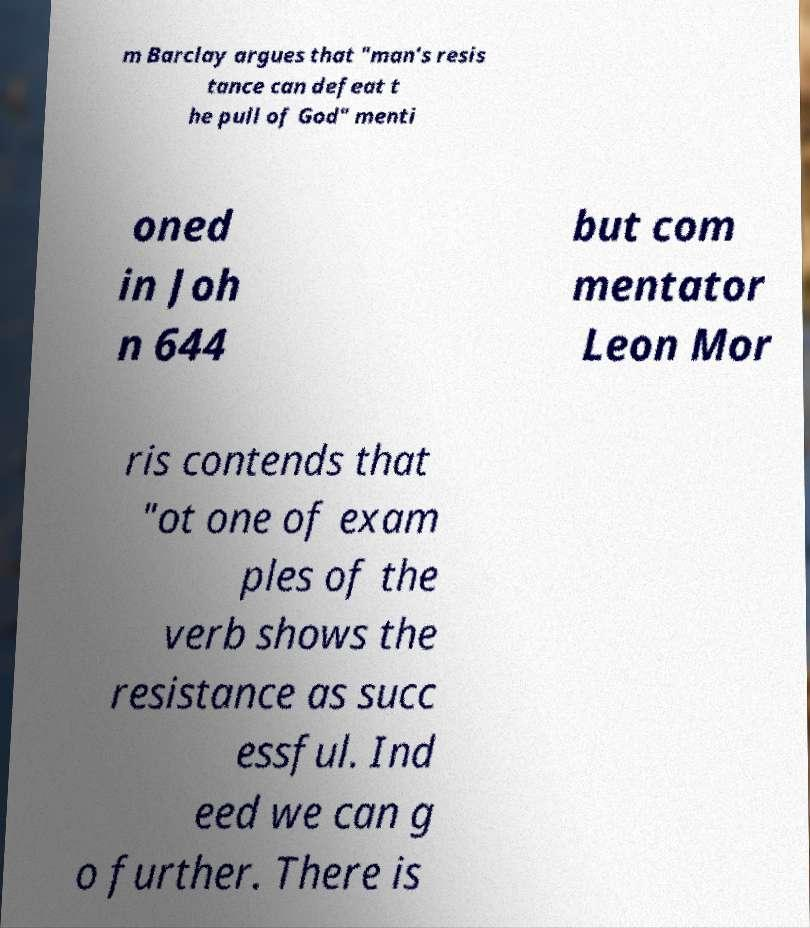Please read and relay the text visible in this image. What does it say? m Barclay argues that "man's resis tance can defeat t he pull of God" menti oned in Joh n 644 but com mentator Leon Mor ris contends that "ot one of exam ples of the verb shows the resistance as succ essful. Ind eed we can g o further. There is 